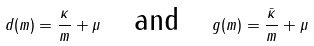Convert formula to latex. <formula><loc_0><loc_0><loc_500><loc_500>d ( m ) = \frac { \kappa } { m } + \mu \quad \text {and} \quad g ( m ) = \frac { \bar { \kappa } } { m } + \mu</formula> 